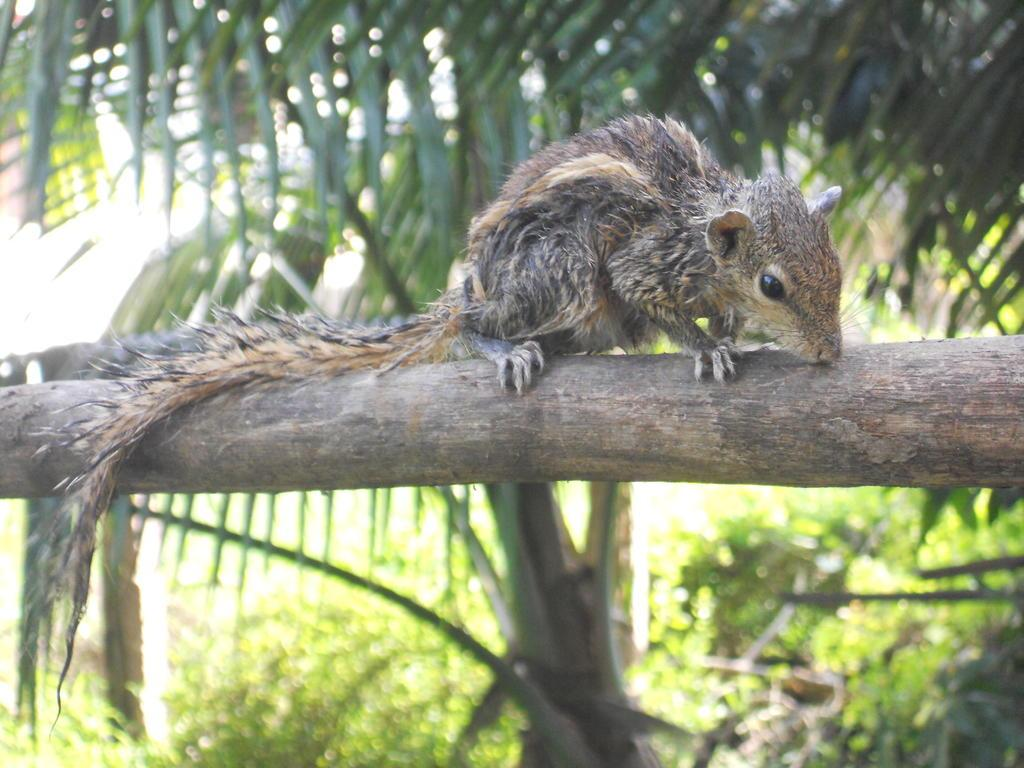What type of natural element is present in the image? There is a tree in the image. What other natural elements can be seen in the image? There are many plants in the image. Can you identify any living creature in the image? Yes, there is an animal in the image. What type of man-made object is visible in the image? There is a wooden object in the image. What type of ice can be seen melting on the wooden object in the image? There is no ice present in the image, so it cannot be melting on the wooden object. 